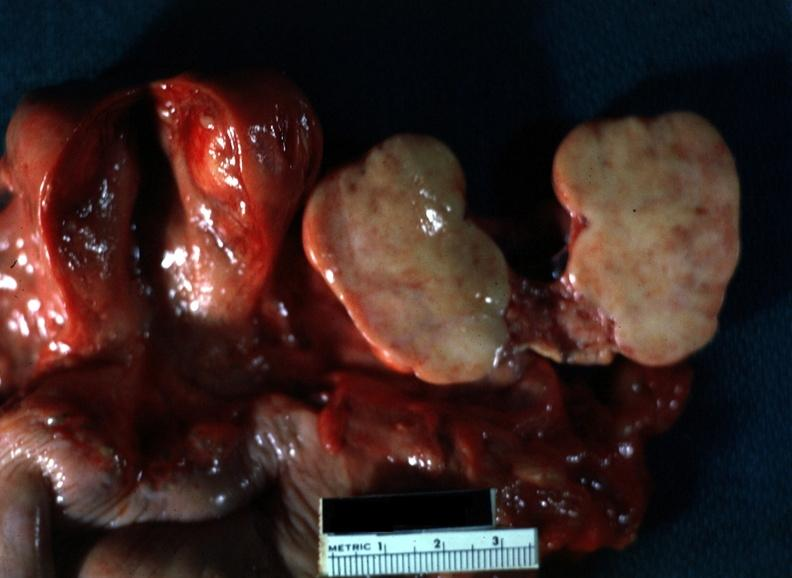what is present?
Answer the question using a single word or phrase. Thecoma 